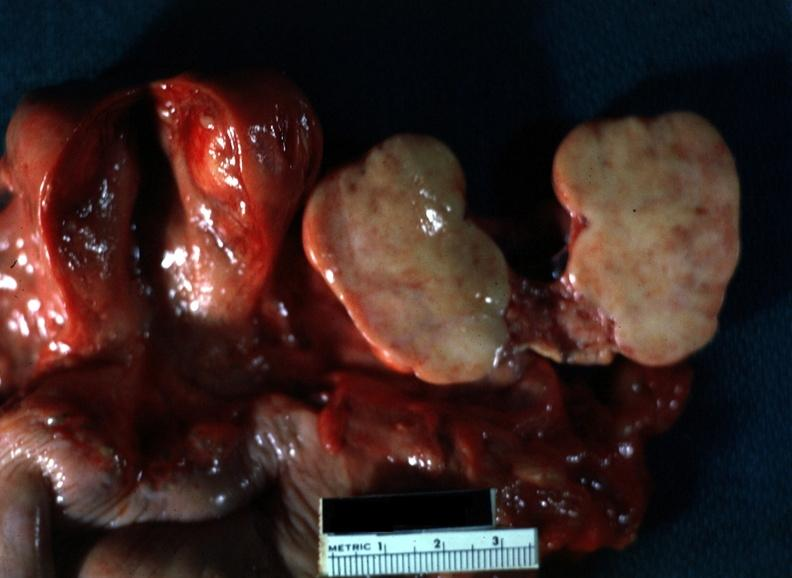what is present?
Answer the question using a single word or phrase. Thecoma 